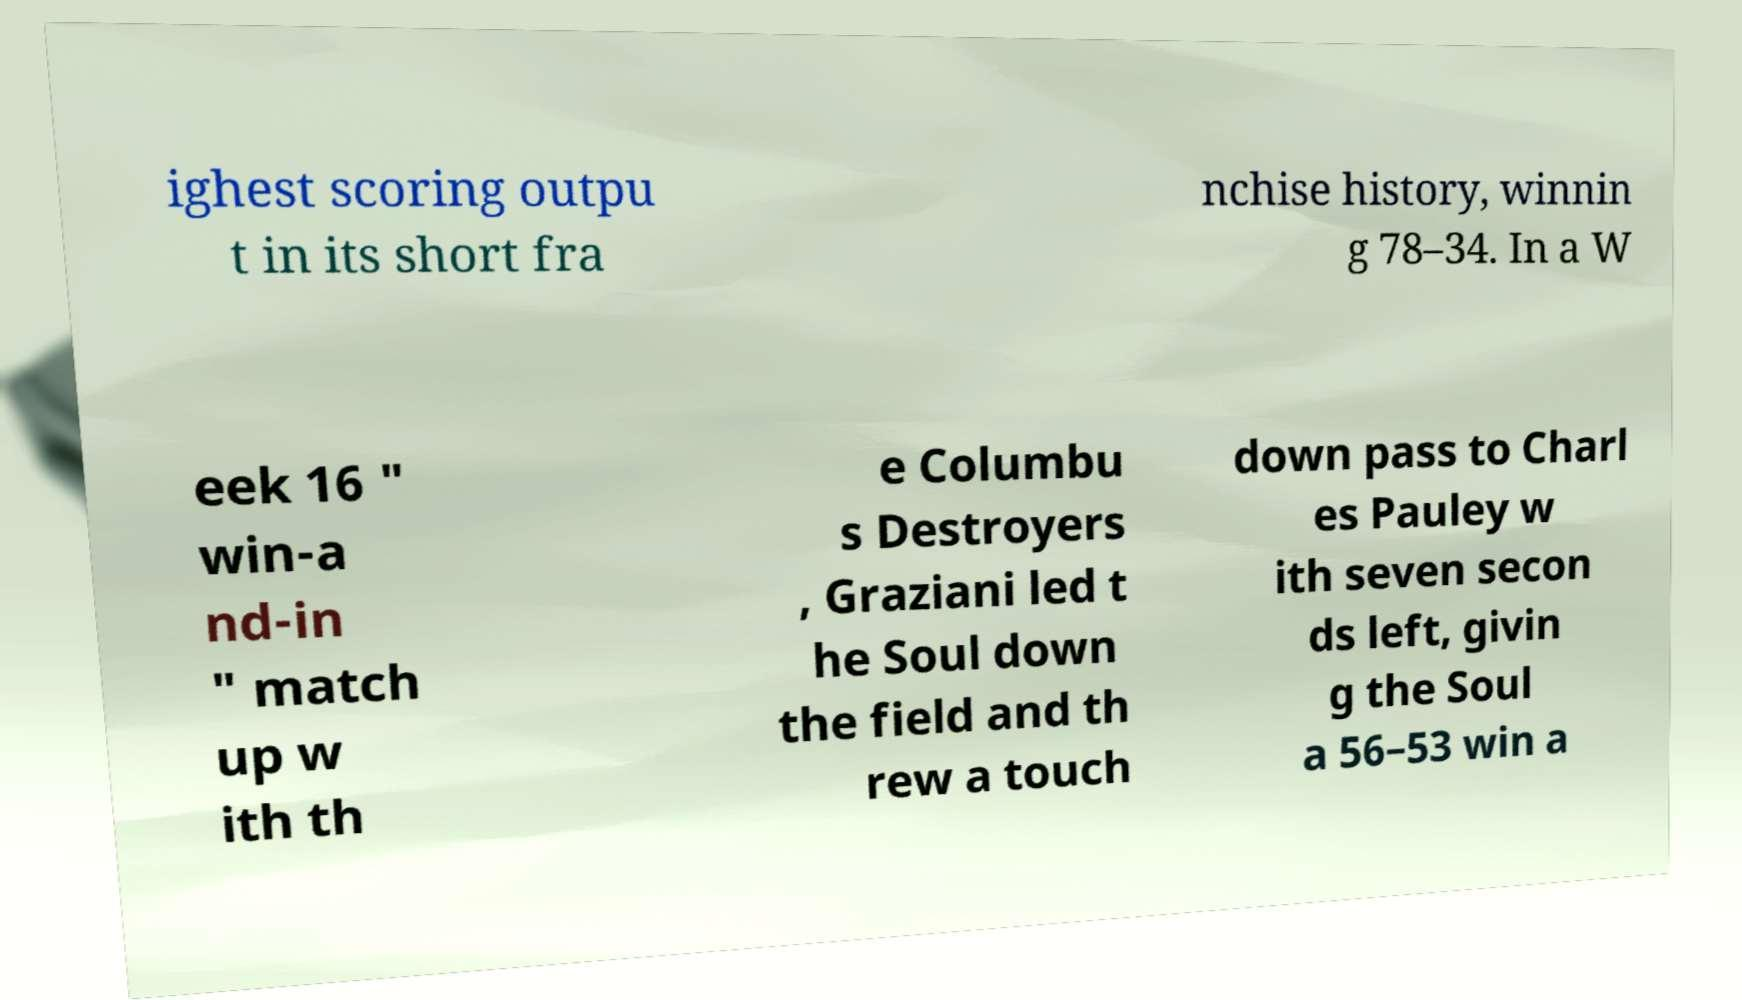I need the written content from this picture converted into text. Can you do that? ighest scoring outpu t in its short fra nchise history, winnin g 78–34. In a W eek 16 " win-a nd-in " match up w ith th e Columbu s Destroyers , Graziani led t he Soul down the field and th rew a touch down pass to Charl es Pauley w ith seven secon ds left, givin g the Soul a 56–53 win a 